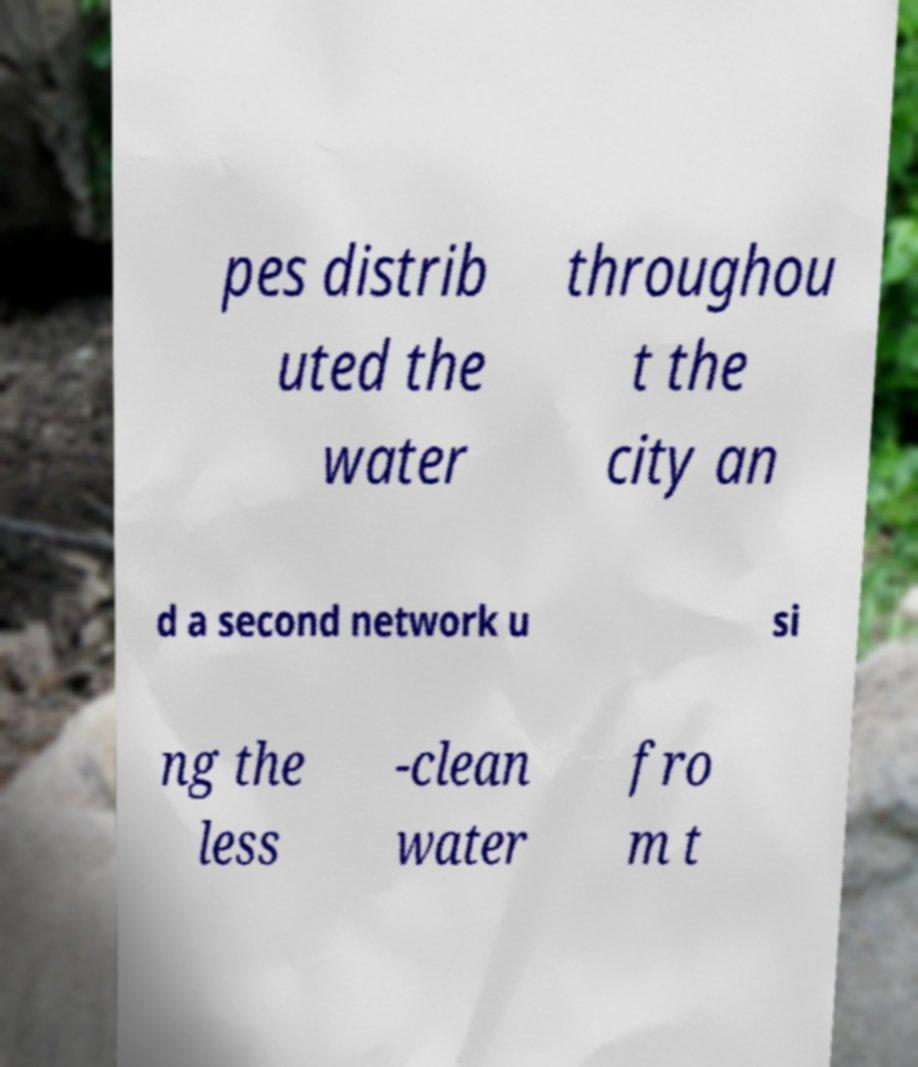Could you extract and type out the text from this image? pes distrib uted the water throughou t the city an d a second network u si ng the less -clean water fro m t 